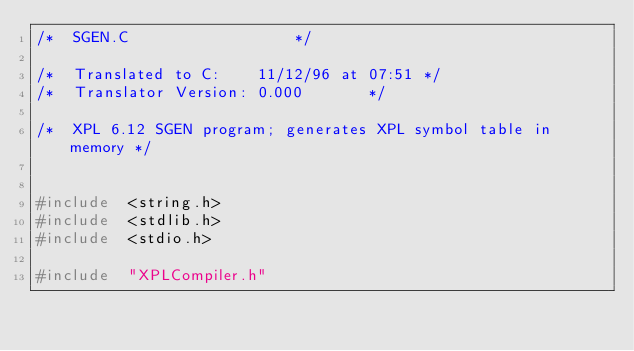Convert code to text. <code><loc_0><loc_0><loc_500><loc_500><_C++_>/*	SGEN.C									*/

/*	Translated to C:   	11/12/96 at 07:51	*/
/*	Translator Version:	0.000				*/

/* 	XPL 6.12 SGEN program; generates XPL symbol table in memory */


#include 	<string.h>
#include 	<stdlib.h>
#include 	<stdio.h>

#include	"XPLCompiler.h"</code> 